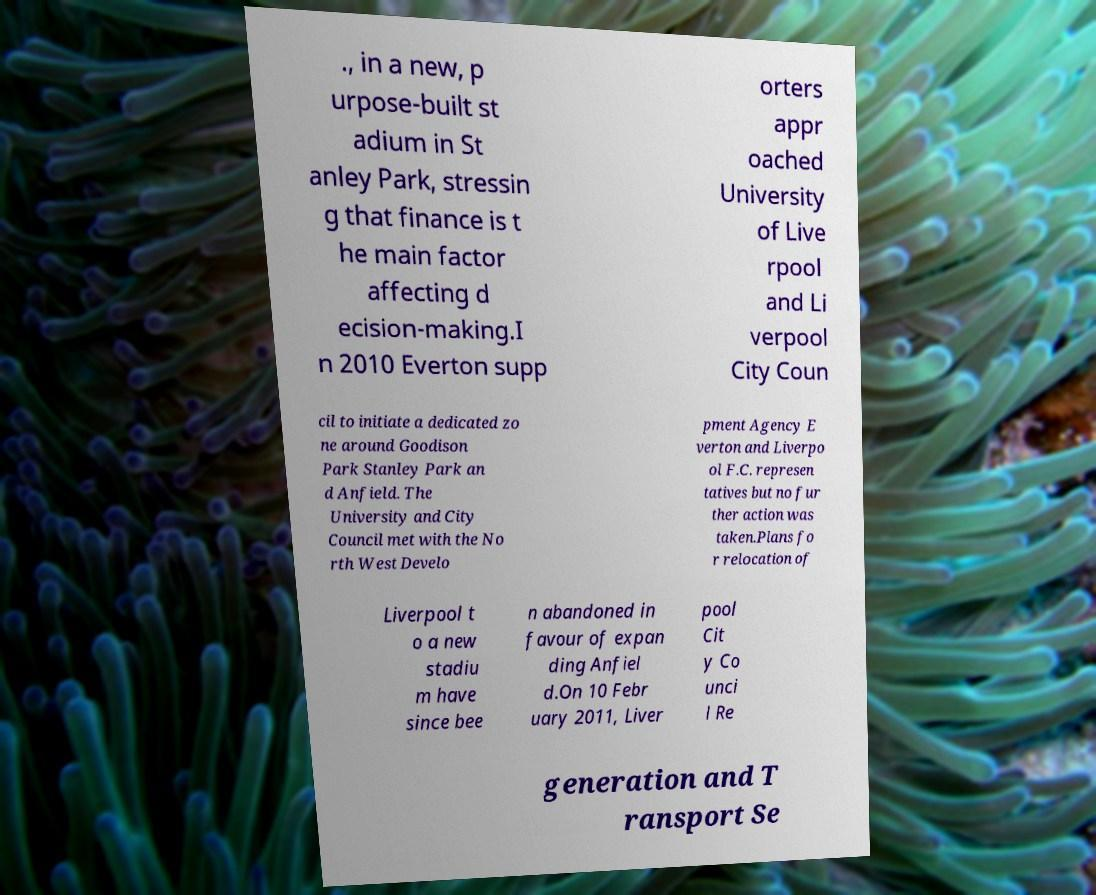Please identify and transcribe the text found in this image. ., in a new, p urpose-built st adium in St anley Park, stressin g that finance is t he main factor affecting d ecision-making.I n 2010 Everton supp orters appr oached University of Live rpool and Li verpool City Coun cil to initiate a dedicated zo ne around Goodison Park Stanley Park an d Anfield. The University and City Council met with the No rth West Develo pment Agency E verton and Liverpo ol F.C. represen tatives but no fur ther action was taken.Plans fo r relocation of Liverpool t o a new stadiu m have since bee n abandoned in favour of expan ding Anfiel d.On 10 Febr uary 2011, Liver pool Cit y Co unci l Re generation and T ransport Se 